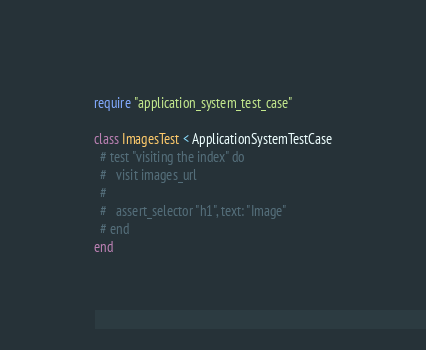Convert code to text. <code><loc_0><loc_0><loc_500><loc_500><_Ruby_>require "application_system_test_case"

class ImagesTest < ApplicationSystemTestCase
  # test "visiting the index" do
  #   visit images_url
  #
  #   assert_selector "h1", text: "Image"
  # end
end
</code> 